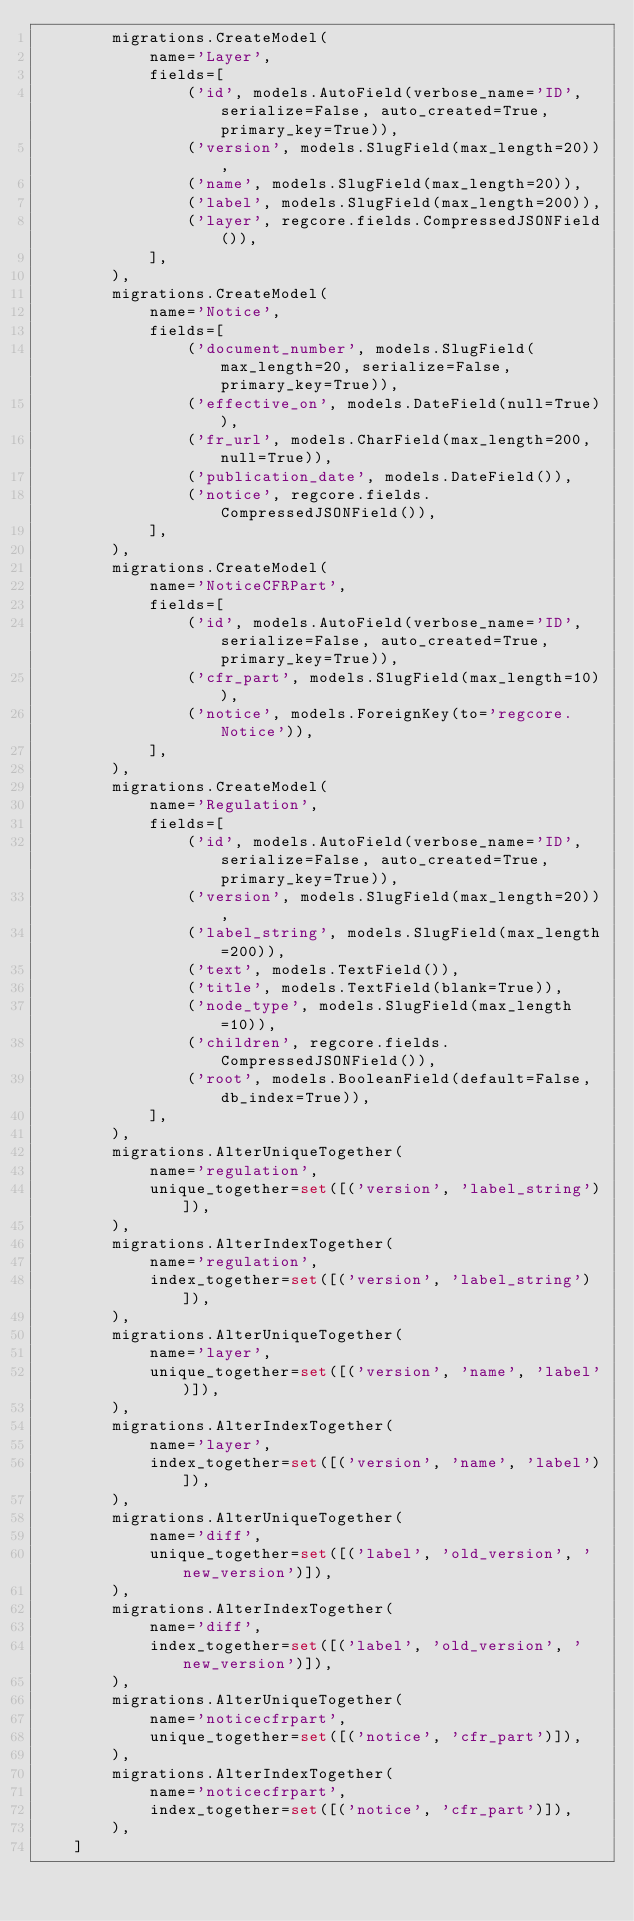<code> <loc_0><loc_0><loc_500><loc_500><_Python_>        migrations.CreateModel(
            name='Layer',
            fields=[
                ('id', models.AutoField(verbose_name='ID', serialize=False, auto_created=True, primary_key=True)),
                ('version', models.SlugField(max_length=20)),
                ('name', models.SlugField(max_length=20)),
                ('label', models.SlugField(max_length=200)),
                ('layer', regcore.fields.CompressedJSONField()),
            ],
        ),
        migrations.CreateModel(
            name='Notice',
            fields=[
                ('document_number', models.SlugField(max_length=20, serialize=False, primary_key=True)),
                ('effective_on', models.DateField(null=True)),
                ('fr_url', models.CharField(max_length=200, null=True)),
                ('publication_date', models.DateField()),
                ('notice', regcore.fields.CompressedJSONField()),
            ],
        ),
        migrations.CreateModel(
            name='NoticeCFRPart',
            fields=[
                ('id', models.AutoField(verbose_name='ID', serialize=False, auto_created=True, primary_key=True)),
                ('cfr_part', models.SlugField(max_length=10)),
                ('notice', models.ForeignKey(to='regcore.Notice')),
            ],
        ),
        migrations.CreateModel(
            name='Regulation',
            fields=[
                ('id', models.AutoField(verbose_name='ID', serialize=False, auto_created=True, primary_key=True)),
                ('version', models.SlugField(max_length=20)),
                ('label_string', models.SlugField(max_length=200)),
                ('text', models.TextField()),
                ('title', models.TextField(blank=True)),
                ('node_type', models.SlugField(max_length=10)),
                ('children', regcore.fields.CompressedJSONField()),
                ('root', models.BooleanField(default=False, db_index=True)),
            ],
        ),
        migrations.AlterUniqueTogether(
            name='regulation',
            unique_together=set([('version', 'label_string')]),
        ),
        migrations.AlterIndexTogether(
            name='regulation',
            index_together=set([('version', 'label_string')]),
        ),
        migrations.AlterUniqueTogether(
            name='layer',
            unique_together=set([('version', 'name', 'label')]),
        ),
        migrations.AlterIndexTogether(
            name='layer',
            index_together=set([('version', 'name', 'label')]),
        ),
        migrations.AlterUniqueTogether(
            name='diff',
            unique_together=set([('label', 'old_version', 'new_version')]),
        ),
        migrations.AlterIndexTogether(
            name='diff',
            index_together=set([('label', 'old_version', 'new_version')]),
        ),
        migrations.AlterUniqueTogether(
            name='noticecfrpart',
            unique_together=set([('notice', 'cfr_part')]),
        ),
        migrations.AlterIndexTogether(
            name='noticecfrpart',
            index_together=set([('notice', 'cfr_part')]),
        ),
    ]
</code> 